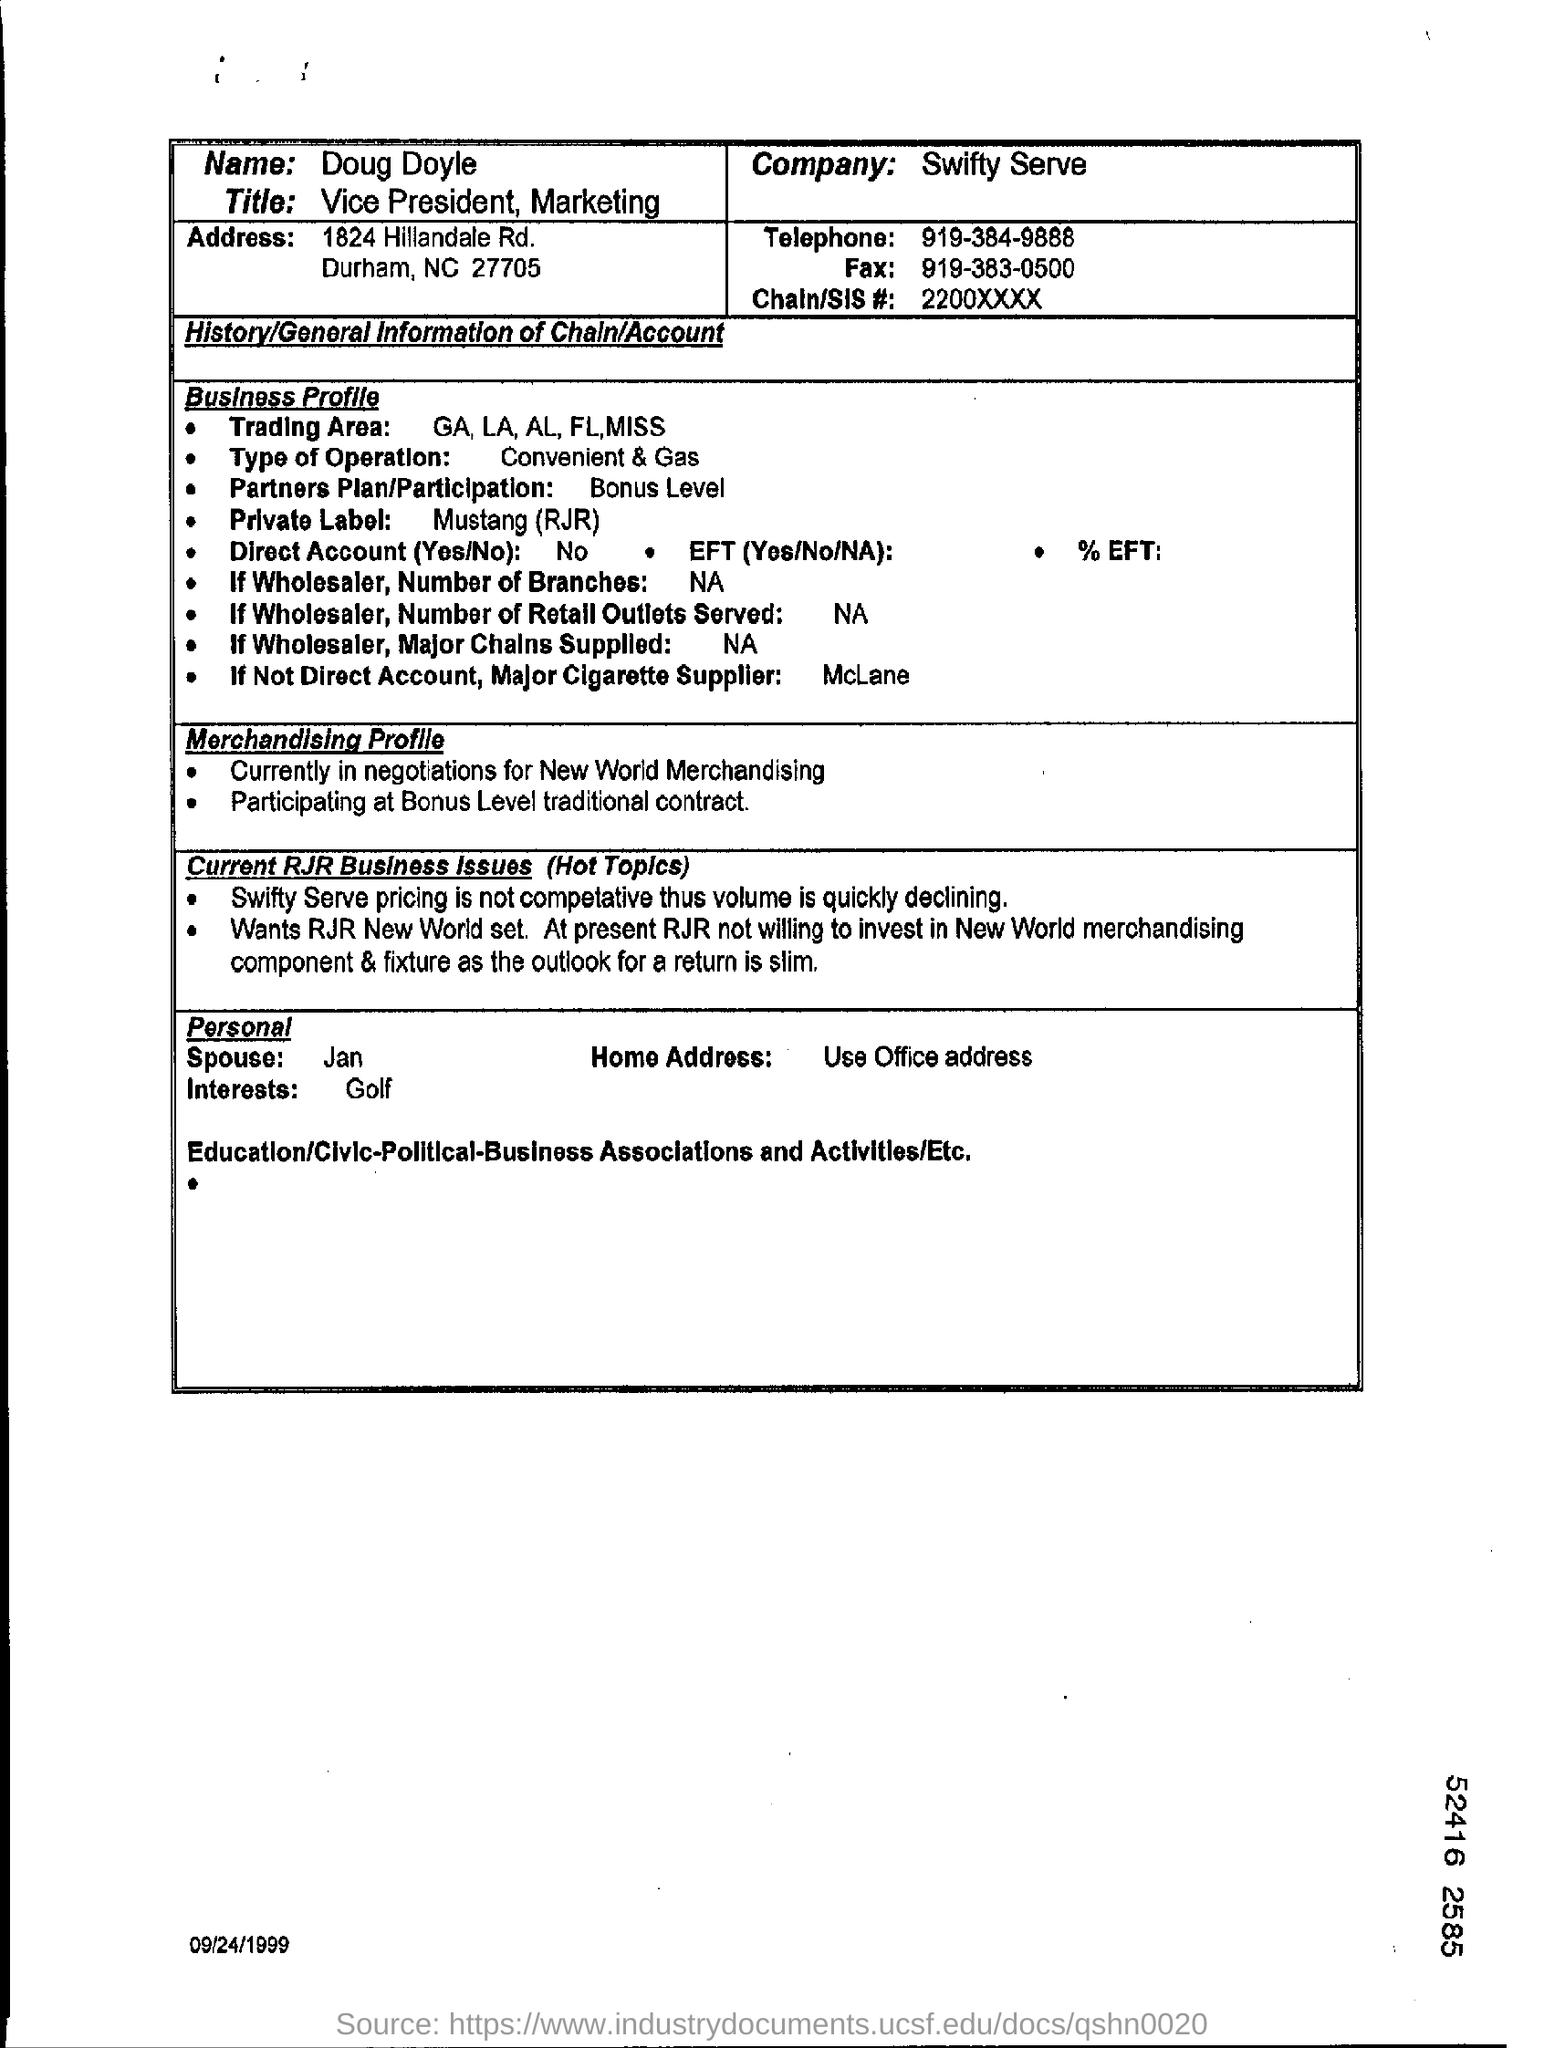Whose profile is given here?
Give a very brief answer. Doug Doyle. What is the job title of Doug Doyle?
Ensure brevity in your answer.  VICE PRESIDENT, MARKETING. What is the Chain/SIS# mentioned in the document?
Offer a very short reply. 2200XXXX. In which company, Doug Doyle works?
Offer a very short reply. Swifty Serve. What is the fax no of Doug Doyle?
Offer a terse response. 919-383-0500. What is the telephone no of Doug Doyle?
Provide a succinct answer. 919-384-9888. 